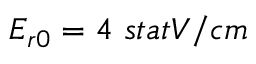<formula> <loc_0><loc_0><loc_500><loc_500>E _ { r 0 } = 4 { s t a t V / c m }</formula> 